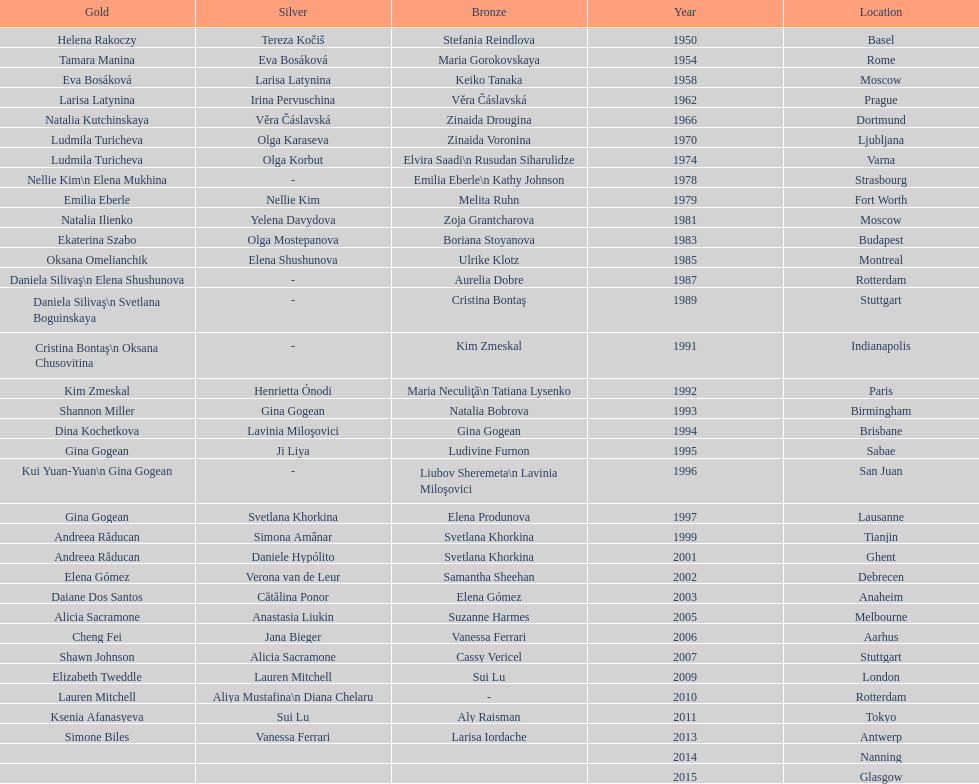Where was the global artistic gymnastics event held prior to san juan? Sabae. 